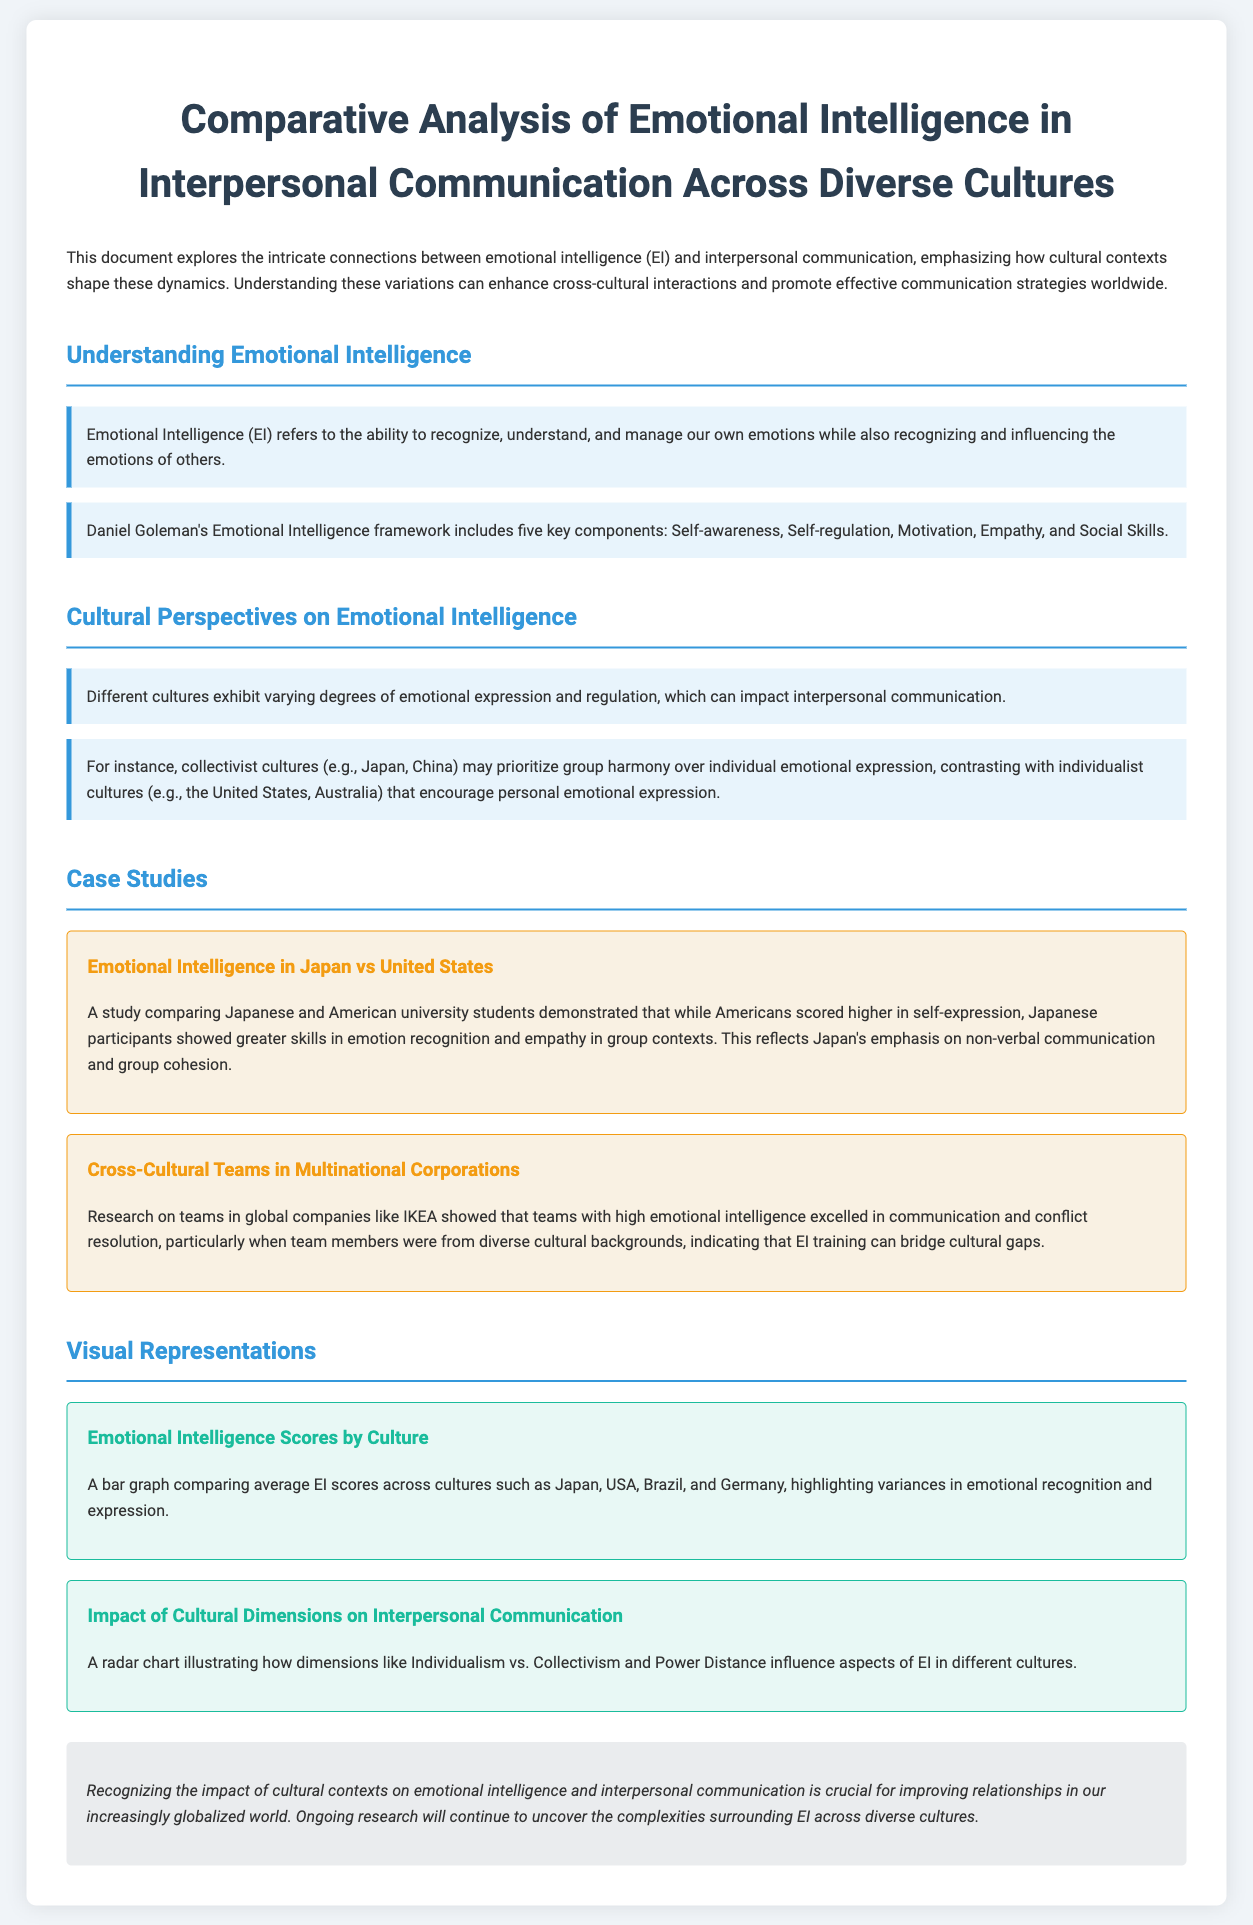What is the title of the document? The title of the document is found in the header section, focusing on emotional intelligence and cultural differences.
Answer: Comparative Analysis of Emotional Intelligence in Interpersonal Communication Across Diverse Cultures Which countries are compared in the case study? The case studies specifically mention Japan and the United States for a comparison of emotional intelligence.
Answer: Japan and United States What are the five key components of Emotional Intelligence according to Goleman? The document outlines Daniel Goleman's framework that includes five components, providing clear definitions for each.
Answer: Self-awareness, Self-regulation, Motivation, Empathy, Social Skills What cultural perspective is emphasized in collectivist cultures? The document explains that collectivist cultures prioritize a specific aspect during communication, which differs from individualist cultures.
Answer: Group harmony Which global company is highlighted for its cross-cultural teams? The document mentions a specific multinational corporation known for its diverse teams and effective communication strategies.
Answer: IKEA What does the bar graph represent in the document? The bar graph visually compares specific scores for emotional intelligence across selected countries, illustrating key differences.
Answer: Average EI scores across cultures What does the radar chart illustrate? The radar chart in the document visually depicts how cultural dimensions affect specific aspects of emotional intelligence in various contexts.
Answer: Individualism vs. Collectivism and Power Distance What is mentioned as ongoing research in the conclusion? The conclusion emphasizes the importance of research regarding cultural contexts affecting human interaction and emotional intelligence.
Answer: Complexities surrounding EI across diverse cultures 